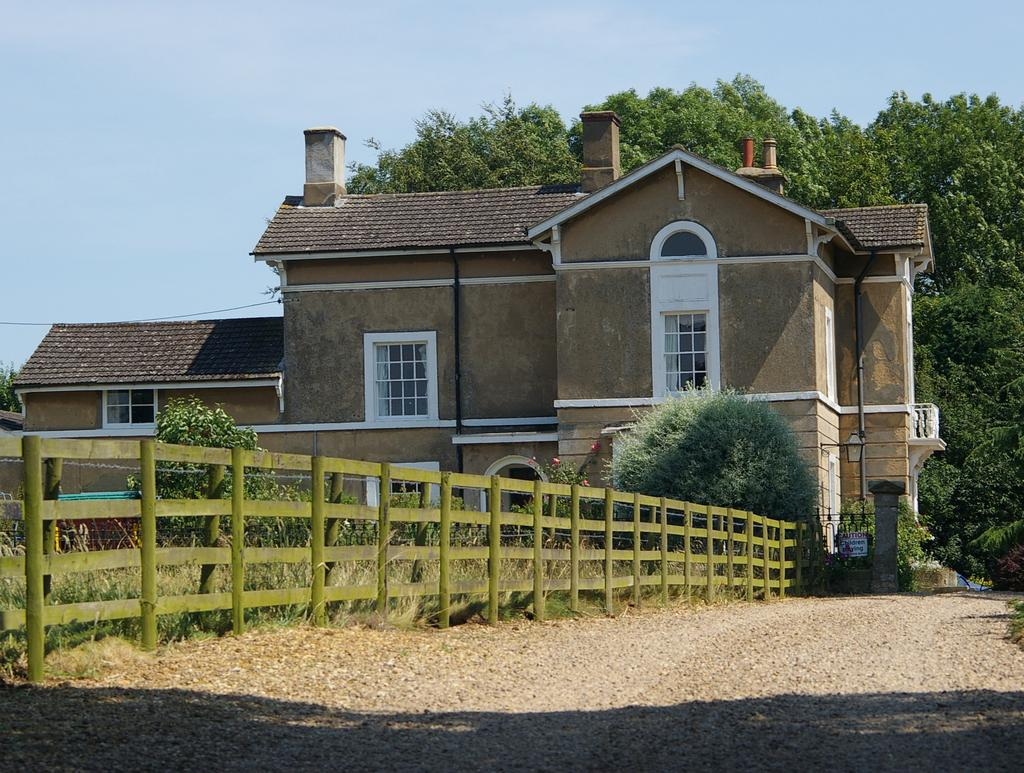What is the main structure in the center of the image? There is a building in the center of the image. What is located at the bottom of the image? There is a fence at the bottom of the image. What type of vegetation is near the fence? There are bushes near the fence. What can be seen in the background of the image? There are trees and the sky visible in the background of the image. Can you hear any noise coming from the building in the image? The image is silent, so it is not possible to hear any noise coming from the building. 